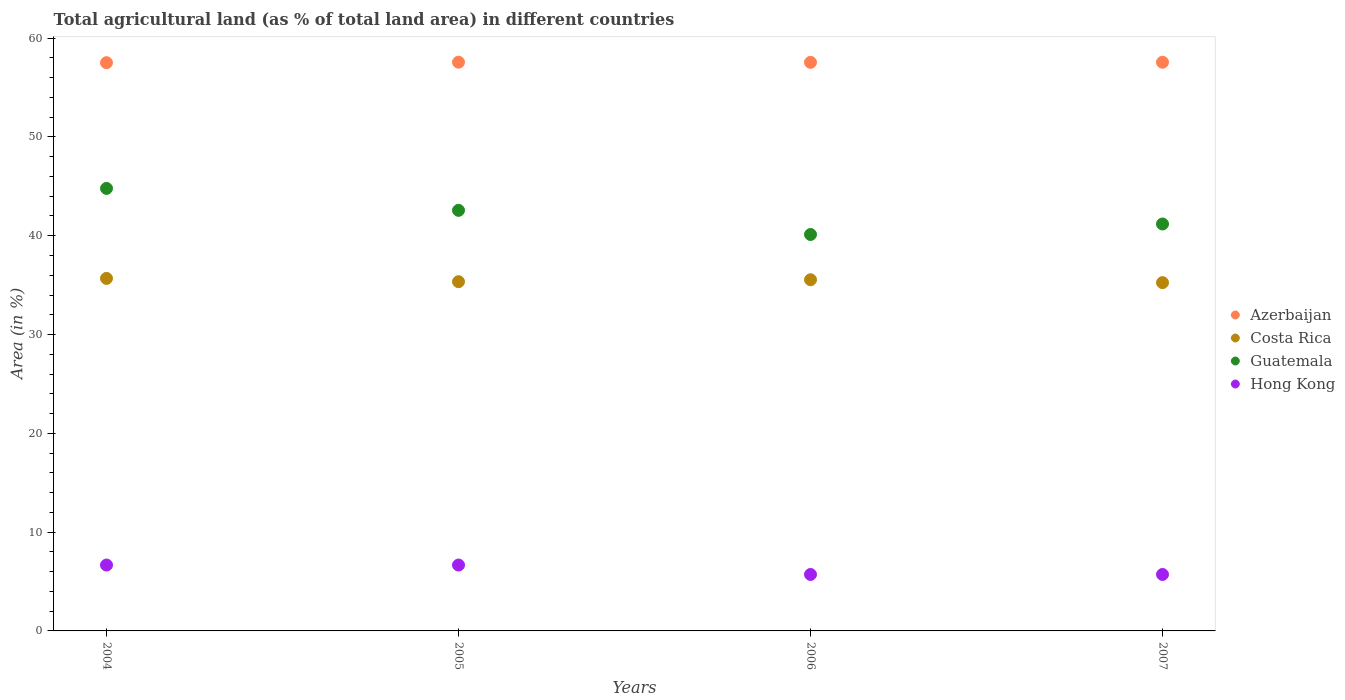What is the percentage of agricultural land in Costa Rica in 2005?
Your answer should be very brief. 35.35. Across all years, what is the maximum percentage of agricultural land in Guatemala?
Ensure brevity in your answer.  44.79. Across all years, what is the minimum percentage of agricultural land in Guatemala?
Offer a terse response. 40.13. In which year was the percentage of agricultural land in Hong Kong maximum?
Your answer should be compact. 2004. What is the total percentage of agricultural land in Costa Rica in the graph?
Your answer should be very brief. 141.83. What is the difference between the percentage of agricultural land in Costa Rica in 2004 and that in 2005?
Provide a succinct answer. 0.33. What is the difference between the percentage of agricultural land in Azerbaijan in 2005 and the percentage of agricultural land in Costa Rica in 2007?
Provide a short and direct response. 22.32. What is the average percentage of agricultural land in Hong Kong per year?
Keep it short and to the point. 6.19. In the year 2006, what is the difference between the percentage of agricultural land in Hong Kong and percentage of agricultural land in Guatemala?
Give a very brief answer. -34.41. What is the ratio of the percentage of agricultural land in Hong Kong in 2005 to that in 2007?
Your answer should be compact. 1.17. What is the difference between the highest and the second highest percentage of agricultural land in Hong Kong?
Your response must be concise. 0. What is the difference between the highest and the lowest percentage of agricultural land in Azerbaijan?
Keep it short and to the point. 0.05. In how many years, is the percentage of agricultural land in Azerbaijan greater than the average percentage of agricultural land in Azerbaijan taken over all years?
Make the answer very short. 3. Is it the case that in every year, the sum of the percentage of agricultural land in Guatemala and percentage of agricultural land in Hong Kong  is greater than the sum of percentage of agricultural land in Azerbaijan and percentage of agricultural land in Costa Rica?
Provide a short and direct response. No. Is it the case that in every year, the sum of the percentage of agricultural land in Guatemala and percentage of agricultural land in Costa Rica  is greater than the percentage of agricultural land in Hong Kong?
Your answer should be very brief. Yes. How many years are there in the graph?
Make the answer very short. 4. What is the difference between two consecutive major ticks on the Y-axis?
Your answer should be very brief. 10. Does the graph contain any zero values?
Provide a succinct answer. No. Does the graph contain grids?
Ensure brevity in your answer.  No. Where does the legend appear in the graph?
Provide a short and direct response. Center right. How many legend labels are there?
Offer a very short reply. 4. How are the legend labels stacked?
Offer a very short reply. Vertical. What is the title of the graph?
Keep it short and to the point. Total agricultural land (as % of total land area) in different countries. What is the label or title of the Y-axis?
Your response must be concise. Area (in %). What is the Area (in %) in Azerbaijan in 2004?
Provide a short and direct response. 57.52. What is the Area (in %) in Costa Rica in 2004?
Your response must be concise. 35.68. What is the Area (in %) in Guatemala in 2004?
Your answer should be very brief. 44.79. What is the Area (in %) in Hong Kong in 2004?
Your answer should be compact. 6.67. What is the Area (in %) of Azerbaijan in 2005?
Your answer should be compact. 57.57. What is the Area (in %) of Costa Rica in 2005?
Keep it short and to the point. 35.35. What is the Area (in %) in Guatemala in 2005?
Make the answer very short. 42.57. What is the Area (in %) in Hong Kong in 2005?
Offer a very short reply. 6.67. What is the Area (in %) of Azerbaijan in 2006?
Give a very brief answer. 57.55. What is the Area (in %) of Costa Rica in 2006?
Keep it short and to the point. 35.55. What is the Area (in %) of Guatemala in 2006?
Ensure brevity in your answer.  40.13. What is the Area (in %) in Hong Kong in 2006?
Ensure brevity in your answer.  5.71. What is the Area (in %) of Azerbaijan in 2007?
Offer a very short reply. 57.56. What is the Area (in %) in Costa Rica in 2007?
Your answer should be compact. 35.25. What is the Area (in %) of Guatemala in 2007?
Make the answer very short. 41.19. What is the Area (in %) in Hong Kong in 2007?
Give a very brief answer. 5.71. Across all years, what is the maximum Area (in %) of Azerbaijan?
Your answer should be compact. 57.57. Across all years, what is the maximum Area (in %) in Costa Rica?
Make the answer very short. 35.68. Across all years, what is the maximum Area (in %) in Guatemala?
Your answer should be very brief. 44.79. Across all years, what is the maximum Area (in %) in Hong Kong?
Offer a very short reply. 6.67. Across all years, what is the minimum Area (in %) of Azerbaijan?
Ensure brevity in your answer.  57.52. Across all years, what is the minimum Area (in %) of Costa Rica?
Your answer should be very brief. 35.25. Across all years, what is the minimum Area (in %) in Guatemala?
Provide a short and direct response. 40.13. Across all years, what is the minimum Area (in %) in Hong Kong?
Offer a very short reply. 5.71. What is the total Area (in %) of Azerbaijan in the graph?
Offer a very short reply. 230.2. What is the total Area (in %) of Costa Rica in the graph?
Provide a short and direct response. 141.83. What is the total Area (in %) in Guatemala in the graph?
Your response must be concise. 168.68. What is the total Area (in %) of Hong Kong in the graph?
Your response must be concise. 24.76. What is the difference between the Area (in %) in Azerbaijan in 2004 and that in 2005?
Offer a terse response. -0.05. What is the difference between the Area (in %) in Costa Rica in 2004 and that in 2005?
Provide a short and direct response. 0.33. What is the difference between the Area (in %) of Guatemala in 2004 and that in 2005?
Your answer should be very brief. 2.22. What is the difference between the Area (in %) in Hong Kong in 2004 and that in 2005?
Offer a terse response. 0. What is the difference between the Area (in %) in Azerbaijan in 2004 and that in 2006?
Make the answer very short. -0.04. What is the difference between the Area (in %) in Costa Rica in 2004 and that in 2006?
Offer a terse response. 0.14. What is the difference between the Area (in %) in Guatemala in 2004 and that in 2006?
Provide a short and direct response. 4.67. What is the difference between the Area (in %) of Hong Kong in 2004 and that in 2006?
Provide a succinct answer. 0.95. What is the difference between the Area (in %) in Azerbaijan in 2004 and that in 2007?
Provide a short and direct response. -0.05. What is the difference between the Area (in %) of Costa Rica in 2004 and that in 2007?
Your answer should be very brief. 0.43. What is the difference between the Area (in %) in Guatemala in 2004 and that in 2007?
Ensure brevity in your answer.  3.6. What is the difference between the Area (in %) of Azerbaijan in 2005 and that in 2006?
Ensure brevity in your answer.  0.02. What is the difference between the Area (in %) in Costa Rica in 2005 and that in 2006?
Provide a succinct answer. -0.2. What is the difference between the Area (in %) in Guatemala in 2005 and that in 2006?
Keep it short and to the point. 2.44. What is the difference between the Area (in %) in Hong Kong in 2005 and that in 2006?
Offer a very short reply. 0.95. What is the difference between the Area (in %) of Azerbaijan in 2005 and that in 2007?
Make the answer very short. 0. What is the difference between the Area (in %) of Costa Rica in 2005 and that in 2007?
Your answer should be very brief. 0.1. What is the difference between the Area (in %) in Guatemala in 2005 and that in 2007?
Keep it short and to the point. 1.38. What is the difference between the Area (in %) of Hong Kong in 2005 and that in 2007?
Ensure brevity in your answer.  0.95. What is the difference between the Area (in %) in Azerbaijan in 2006 and that in 2007?
Offer a terse response. -0.01. What is the difference between the Area (in %) of Costa Rica in 2006 and that in 2007?
Offer a very short reply. 0.29. What is the difference between the Area (in %) in Guatemala in 2006 and that in 2007?
Offer a very short reply. -1.06. What is the difference between the Area (in %) of Hong Kong in 2006 and that in 2007?
Offer a very short reply. 0. What is the difference between the Area (in %) of Azerbaijan in 2004 and the Area (in %) of Costa Rica in 2005?
Your answer should be very brief. 22.16. What is the difference between the Area (in %) in Azerbaijan in 2004 and the Area (in %) in Guatemala in 2005?
Your response must be concise. 14.94. What is the difference between the Area (in %) in Azerbaijan in 2004 and the Area (in %) in Hong Kong in 2005?
Provide a succinct answer. 50.85. What is the difference between the Area (in %) in Costa Rica in 2004 and the Area (in %) in Guatemala in 2005?
Your response must be concise. -6.89. What is the difference between the Area (in %) in Costa Rica in 2004 and the Area (in %) in Hong Kong in 2005?
Keep it short and to the point. 29.02. What is the difference between the Area (in %) of Guatemala in 2004 and the Area (in %) of Hong Kong in 2005?
Your response must be concise. 38.13. What is the difference between the Area (in %) of Azerbaijan in 2004 and the Area (in %) of Costa Rica in 2006?
Make the answer very short. 21.97. What is the difference between the Area (in %) in Azerbaijan in 2004 and the Area (in %) in Guatemala in 2006?
Keep it short and to the point. 17.39. What is the difference between the Area (in %) of Azerbaijan in 2004 and the Area (in %) of Hong Kong in 2006?
Provide a succinct answer. 51.8. What is the difference between the Area (in %) of Costa Rica in 2004 and the Area (in %) of Guatemala in 2006?
Your answer should be very brief. -4.44. What is the difference between the Area (in %) in Costa Rica in 2004 and the Area (in %) in Hong Kong in 2006?
Make the answer very short. 29.97. What is the difference between the Area (in %) of Guatemala in 2004 and the Area (in %) of Hong Kong in 2006?
Offer a terse response. 39.08. What is the difference between the Area (in %) in Azerbaijan in 2004 and the Area (in %) in Costa Rica in 2007?
Your answer should be very brief. 22.26. What is the difference between the Area (in %) of Azerbaijan in 2004 and the Area (in %) of Guatemala in 2007?
Your response must be concise. 16.32. What is the difference between the Area (in %) in Azerbaijan in 2004 and the Area (in %) in Hong Kong in 2007?
Provide a succinct answer. 51.8. What is the difference between the Area (in %) in Costa Rica in 2004 and the Area (in %) in Guatemala in 2007?
Your response must be concise. -5.51. What is the difference between the Area (in %) of Costa Rica in 2004 and the Area (in %) of Hong Kong in 2007?
Ensure brevity in your answer.  29.97. What is the difference between the Area (in %) of Guatemala in 2004 and the Area (in %) of Hong Kong in 2007?
Your response must be concise. 39.08. What is the difference between the Area (in %) of Azerbaijan in 2005 and the Area (in %) of Costa Rica in 2006?
Your answer should be very brief. 22.02. What is the difference between the Area (in %) of Azerbaijan in 2005 and the Area (in %) of Guatemala in 2006?
Ensure brevity in your answer.  17.44. What is the difference between the Area (in %) of Azerbaijan in 2005 and the Area (in %) of Hong Kong in 2006?
Keep it short and to the point. 51.85. What is the difference between the Area (in %) of Costa Rica in 2005 and the Area (in %) of Guatemala in 2006?
Offer a very short reply. -4.78. What is the difference between the Area (in %) in Costa Rica in 2005 and the Area (in %) in Hong Kong in 2006?
Ensure brevity in your answer.  29.64. What is the difference between the Area (in %) in Guatemala in 2005 and the Area (in %) in Hong Kong in 2006?
Give a very brief answer. 36.86. What is the difference between the Area (in %) of Azerbaijan in 2005 and the Area (in %) of Costa Rica in 2007?
Your answer should be very brief. 22.32. What is the difference between the Area (in %) in Azerbaijan in 2005 and the Area (in %) in Guatemala in 2007?
Ensure brevity in your answer.  16.38. What is the difference between the Area (in %) in Azerbaijan in 2005 and the Area (in %) in Hong Kong in 2007?
Your response must be concise. 51.85. What is the difference between the Area (in %) in Costa Rica in 2005 and the Area (in %) in Guatemala in 2007?
Your answer should be very brief. -5.84. What is the difference between the Area (in %) of Costa Rica in 2005 and the Area (in %) of Hong Kong in 2007?
Make the answer very short. 29.64. What is the difference between the Area (in %) of Guatemala in 2005 and the Area (in %) of Hong Kong in 2007?
Provide a short and direct response. 36.86. What is the difference between the Area (in %) in Azerbaijan in 2006 and the Area (in %) in Costa Rica in 2007?
Offer a terse response. 22.3. What is the difference between the Area (in %) in Azerbaijan in 2006 and the Area (in %) in Guatemala in 2007?
Offer a terse response. 16.36. What is the difference between the Area (in %) of Azerbaijan in 2006 and the Area (in %) of Hong Kong in 2007?
Your answer should be compact. 51.84. What is the difference between the Area (in %) in Costa Rica in 2006 and the Area (in %) in Guatemala in 2007?
Make the answer very short. -5.64. What is the difference between the Area (in %) in Costa Rica in 2006 and the Area (in %) in Hong Kong in 2007?
Give a very brief answer. 29.83. What is the difference between the Area (in %) in Guatemala in 2006 and the Area (in %) in Hong Kong in 2007?
Your answer should be compact. 34.41. What is the average Area (in %) in Azerbaijan per year?
Your answer should be compact. 57.55. What is the average Area (in %) in Costa Rica per year?
Your response must be concise. 35.46. What is the average Area (in %) of Guatemala per year?
Offer a very short reply. 42.17. What is the average Area (in %) in Hong Kong per year?
Your answer should be very brief. 6.19. In the year 2004, what is the difference between the Area (in %) in Azerbaijan and Area (in %) in Costa Rica?
Give a very brief answer. 21.83. In the year 2004, what is the difference between the Area (in %) of Azerbaijan and Area (in %) of Guatemala?
Your response must be concise. 12.72. In the year 2004, what is the difference between the Area (in %) in Azerbaijan and Area (in %) in Hong Kong?
Offer a very short reply. 50.85. In the year 2004, what is the difference between the Area (in %) of Costa Rica and Area (in %) of Guatemala?
Your response must be concise. -9.11. In the year 2004, what is the difference between the Area (in %) in Costa Rica and Area (in %) in Hong Kong?
Ensure brevity in your answer.  29.02. In the year 2004, what is the difference between the Area (in %) in Guatemala and Area (in %) in Hong Kong?
Give a very brief answer. 38.13. In the year 2005, what is the difference between the Area (in %) in Azerbaijan and Area (in %) in Costa Rica?
Offer a terse response. 22.22. In the year 2005, what is the difference between the Area (in %) in Azerbaijan and Area (in %) in Guatemala?
Provide a short and direct response. 15. In the year 2005, what is the difference between the Area (in %) of Azerbaijan and Area (in %) of Hong Kong?
Your answer should be compact. 50.9. In the year 2005, what is the difference between the Area (in %) in Costa Rica and Area (in %) in Guatemala?
Offer a very short reply. -7.22. In the year 2005, what is the difference between the Area (in %) of Costa Rica and Area (in %) of Hong Kong?
Keep it short and to the point. 28.68. In the year 2005, what is the difference between the Area (in %) of Guatemala and Area (in %) of Hong Kong?
Make the answer very short. 35.91. In the year 2006, what is the difference between the Area (in %) in Azerbaijan and Area (in %) in Costa Rica?
Keep it short and to the point. 22.01. In the year 2006, what is the difference between the Area (in %) in Azerbaijan and Area (in %) in Guatemala?
Offer a terse response. 17.43. In the year 2006, what is the difference between the Area (in %) of Azerbaijan and Area (in %) of Hong Kong?
Your answer should be compact. 51.84. In the year 2006, what is the difference between the Area (in %) in Costa Rica and Area (in %) in Guatemala?
Ensure brevity in your answer.  -4.58. In the year 2006, what is the difference between the Area (in %) of Costa Rica and Area (in %) of Hong Kong?
Offer a very short reply. 29.83. In the year 2006, what is the difference between the Area (in %) in Guatemala and Area (in %) in Hong Kong?
Keep it short and to the point. 34.41. In the year 2007, what is the difference between the Area (in %) in Azerbaijan and Area (in %) in Costa Rica?
Your answer should be compact. 22.31. In the year 2007, what is the difference between the Area (in %) of Azerbaijan and Area (in %) of Guatemala?
Ensure brevity in your answer.  16.37. In the year 2007, what is the difference between the Area (in %) in Azerbaijan and Area (in %) in Hong Kong?
Give a very brief answer. 51.85. In the year 2007, what is the difference between the Area (in %) in Costa Rica and Area (in %) in Guatemala?
Ensure brevity in your answer.  -5.94. In the year 2007, what is the difference between the Area (in %) of Costa Rica and Area (in %) of Hong Kong?
Offer a very short reply. 29.54. In the year 2007, what is the difference between the Area (in %) in Guatemala and Area (in %) in Hong Kong?
Offer a terse response. 35.48. What is the ratio of the Area (in %) in Costa Rica in 2004 to that in 2005?
Provide a succinct answer. 1.01. What is the ratio of the Area (in %) in Guatemala in 2004 to that in 2005?
Provide a short and direct response. 1.05. What is the ratio of the Area (in %) of Azerbaijan in 2004 to that in 2006?
Provide a succinct answer. 1. What is the ratio of the Area (in %) in Costa Rica in 2004 to that in 2006?
Ensure brevity in your answer.  1. What is the ratio of the Area (in %) of Guatemala in 2004 to that in 2006?
Give a very brief answer. 1.12. What is the ratio of the Area (in %) in Azerbaijan in 2004 to that in 2007?
Ensure brevity in your answer.  1. What is the ratio of the Area (in %) in Costa Rica in 2004 to that in 2007?
Your answer should be compact. 1.01. What is the ratio of the Area (in %) of Guatemala in 2004 to that in 2007?
Your response must be concise. 1.09. What is the ratio of the Area (in %) in Costa Rica in 2005 to that in 2006?
Provide a short and direct response. 0.99. What is the ratio of the Area (in %) of Guatemala in 2005 to that in 2006?
Your response must be concise. 1.06. What is the ratio of the Area (in %) in Costa Rica in 2005 to that in 2007?
Provide a succinct answer. 1. What is the ratio of the Area (in %) in Guatemala in 2005 to that in 2007?
Provide a succinct answer. 1.03. What is the ratio of the Area (in %) in Hong Kong in 2005 to that in 2007?
Make the answer very short. 1.17. What is the ratio of the Area (in %) of Azerbaijan in 2006 to that in 2007?
Offer a very short reply. 1. What is the ratio of the Area (in %) of Costa Rica in 2006 to that in 2007?
Keep it short and to the point. 1.01. What is the ratio of the Area (in %) of Guatemala in 2006 to that in 2007?
Your answer should be very brief. 0.97. What is the ratio of the Area (in %) in Hong Kong in 2006 to that in 2007?
Offer a very short reply. 1. What is the difference between the highest and the second highest Area (in %) of Azerbaijan?
Give a very brief answer. 0. What is the difference between the highest and the second highest Area (in %) of Costa Rica?
Provide a succinct answer. 0.14. What is the difference between the highest and the second highest Area (in %) in Guatemala?
Offer a very short reply. 2.22. What is the difference between the highest and the lowest Area (in %) of Azerbaijan?
Provide a short and direct response. 0.05. What is the difference between the highest and the lowest Area (in %) of Costa Rica?
Provide a succinct answer. 0.43. What is the difference between the highest and the lowest Area (in %) of Guatemala?
Offer a very short reply. 4.67. 